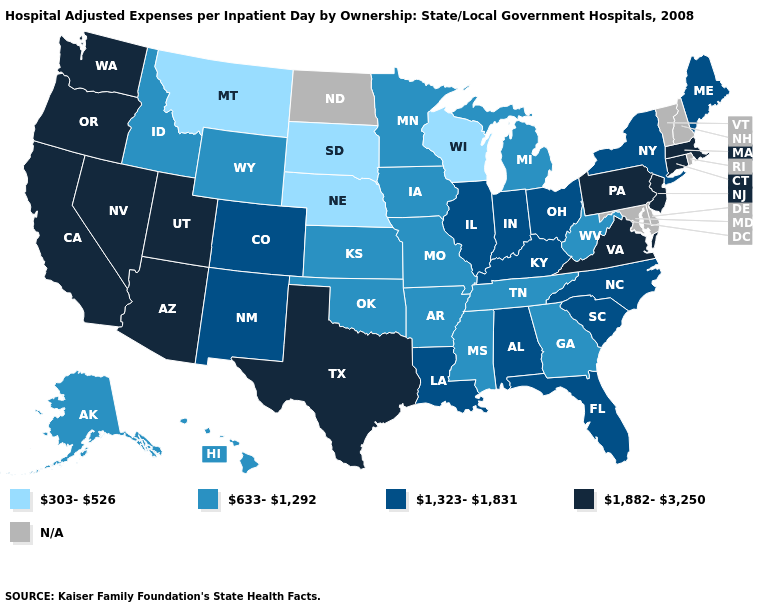Is the legend a continuous bar?
Be succinct. No. Name the states that have a value in the range 303-526?
Short answer required. Montana, Nebraska, South Dakota, Wisconsin. Among the states that border New Hampshire , does Massachusetts have the lowest value?
Quick response, please. No. What is the lowest value in states that border Colorado?
Short answer required. 303-526. What is the value of Mississippi?
Be succinct. 633-1,292. What is the value of Virginia?
Short answer required. 1,882-3,250. Among the states that border New Mexico , which have the lowest value?
Give a very brief answer. Oklahoma. What is the value of Wyoming?
Answer briefly. 633-1,292. Does the map have missing data?
Write a very short answer. Yes. What is the value of Utah?
Short answer required. 1,882-3,250. What is the value of Arizona?
Write a very short answer. 1,882-3,250. Name the states that have a value in the range 633-1,292?
Give a very brief answer. Alaska, Arkansas, Georgia, Hawaii, Idaho, Iowa, Kansas, Michigan, Minnesota, Mississippi, Missouri, Oklahoma, Tennessee, West Virginia, Wyoming. Does the first symbol in the legend represent the smallest category?
Quick response, please. Yes. Among the states that border Louisiana , which have the highest value?
Give a very brief answer. Texas. 